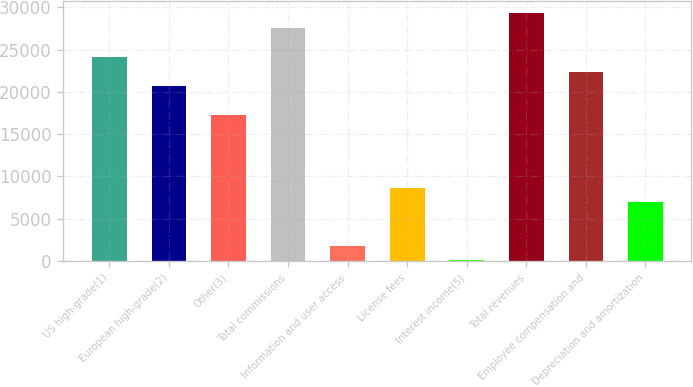Convert chart to OTSL. <chart><loc_0><loc_0><loc_500><loc_500><bar_chart><fcel>US high-grade(1)<fcel>European high-grade(2)<fcel>Other(3)<fcel>Total commissions<fcel>Information and user access<fcel>License fees<fcel>Interest income(5)<fcel>Total revenues<fcel>Employee compensation and<fcel>Depreciation and amortization<nl><fcel>24110.8<fcel>20681.4<fcel>17252<fcel>27540.2<fcel>1819.7<fcel>8678.5<fcel>105<fcel>29254.9<fcel>22396.1<fcel>6963.8<nl></chart> 